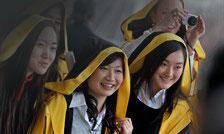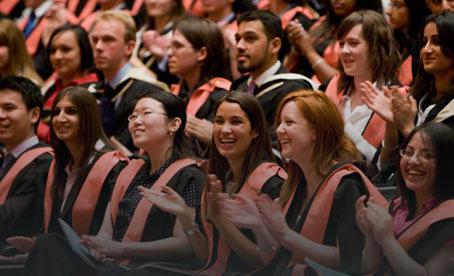The first image is the image on the left, the second image is the image on the right. For the images displayed, is the sentence "At least three people are wearing yellow graduation stoles in the image on the left." factually correct? Answer yes or no. Yes. The first image is the image on the left, the second image is the image on the right. For the images shown, is this caption "Multiple young women in black and yellow stand in the foreground of an image." true? Answer yes or no. Yes. 